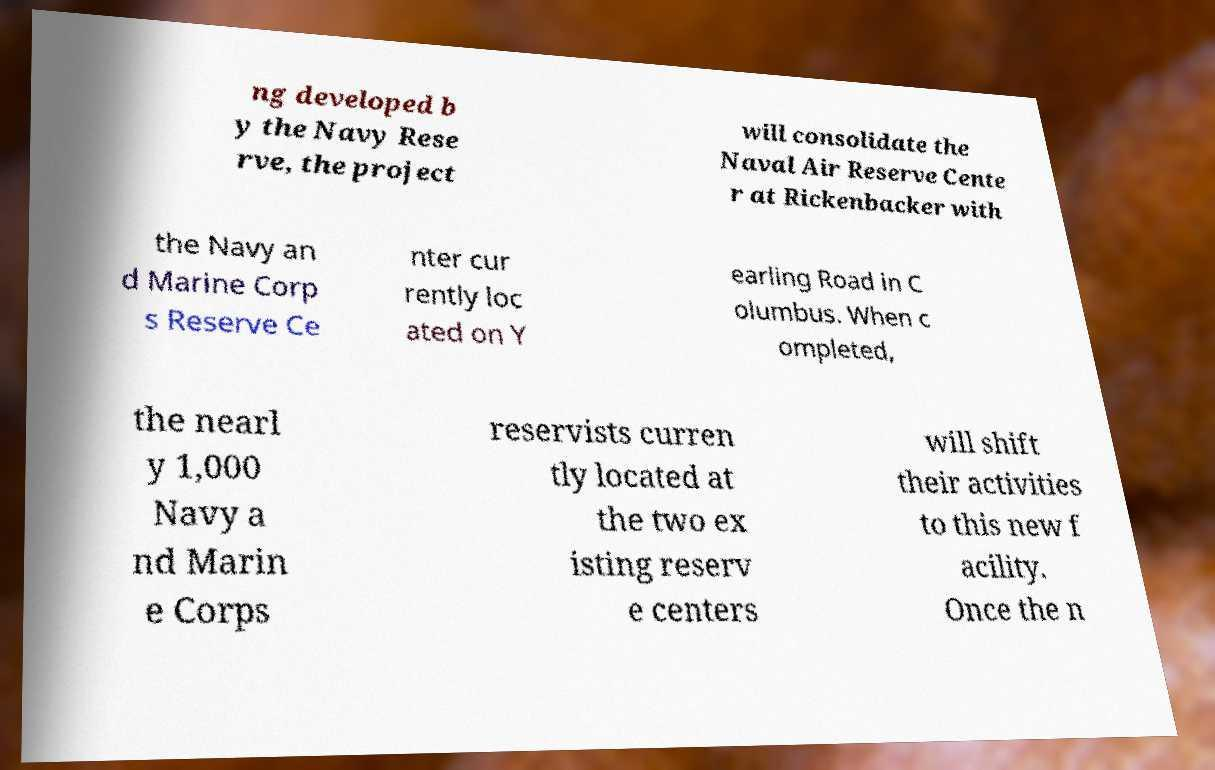Could you extract and type out the text from this image? ng developed b y the Navy Rese rve, the project will consolidate the Naval Air Reserve Cente r at Rickenbacker with the Navy an d Marine Corp s Reserve Ce nter cur rently loc ated on Y earling Road in C olumbus. When c ompleted, the nearl y 1,000 Navy a nd Marin e Corps reservists curren tly located at the two ex isting reserv e centers will shift their activities to this new f acility. Once the n 